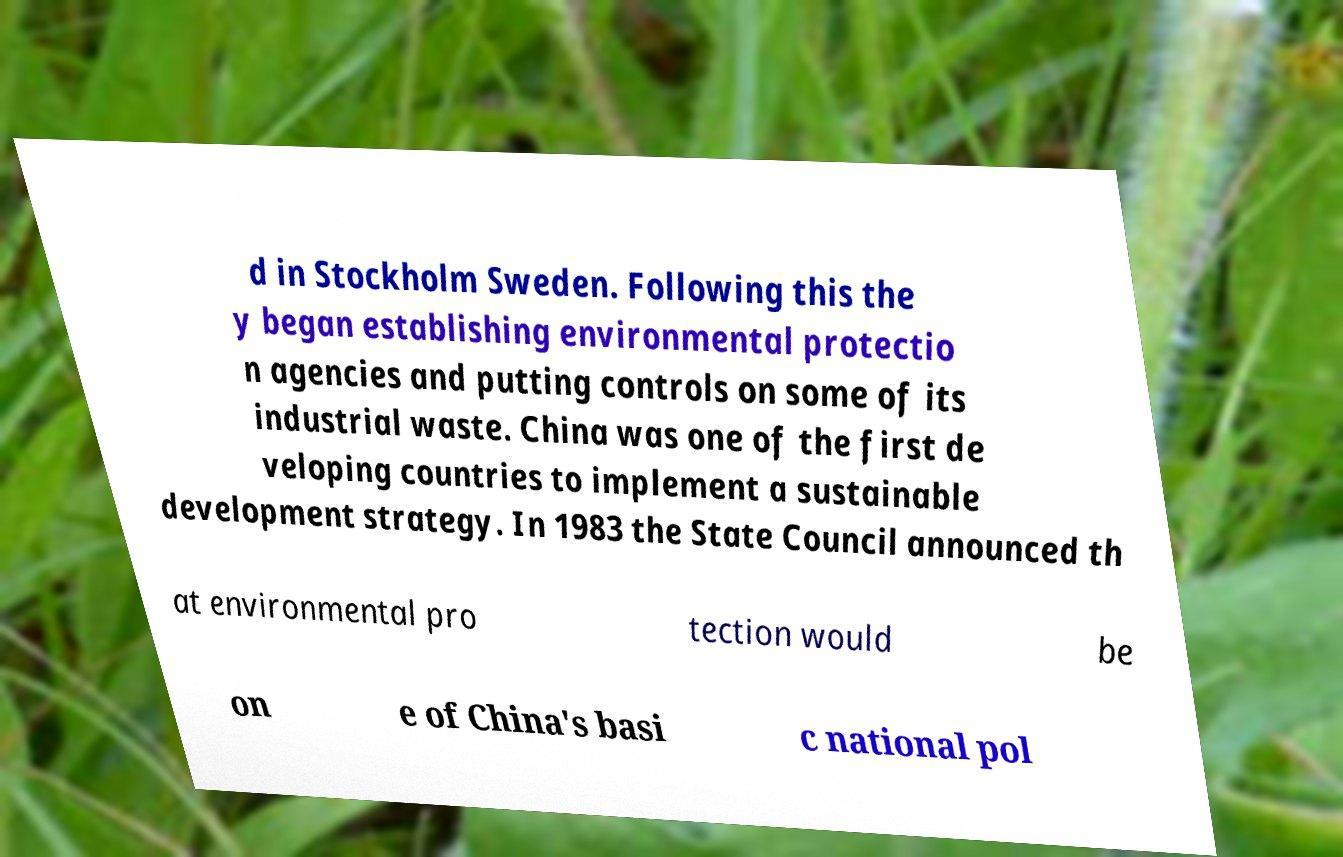Please identify and transcribe the text found in this image. d in Stockholm Sweden. Following this the y began establishing environmental protectio n agencies and putting controls on some of its industrial waste. China was one of the first de veloping countries to implement a sustainable development strategy. In 1983 the State Council announced th at environmental pro tection would be on e of China's basi c national pol 